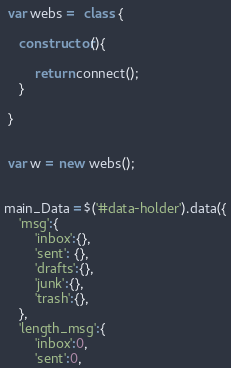<code> <loc_0><loc_0><loc_500><loc_500><_JavaScript_>
 var webs =  class {

 	constructor(){

 		return connect();
 	}

 }


 var w = new webs();


main_Data =$('#data-holder').data({
	'msg':{
		'inbox':{},
		'sent': {},
		'drafts':{},
		'junk':{},
		'trash':{},
	},
	'length_msg':{
		'inbox':0,
		'sent':0,</code> 